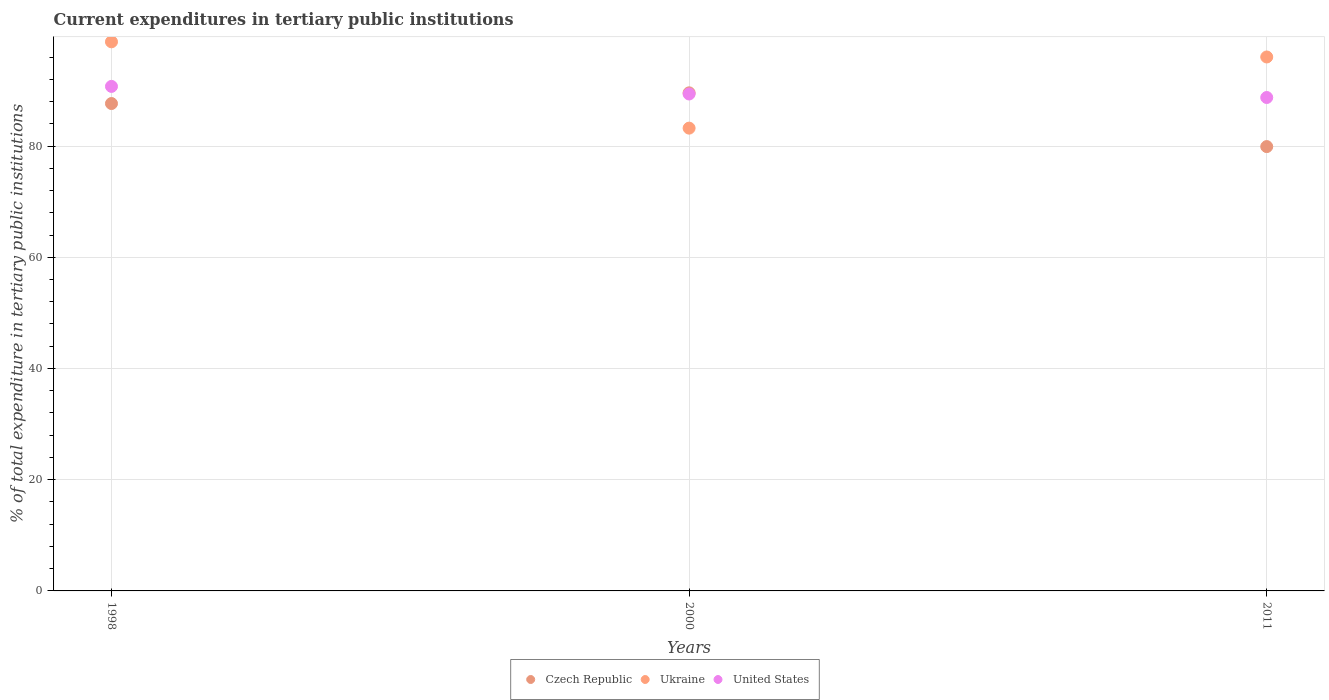How many different coloured dotlines are there?
Your answer should be very brief. 3. What is the current expenditures in tertiary public institutions in United States in 2000?
Offer a terse response. 89.36. Across all years, what is the maximum current expenditures in tertiary public institutions in United States?
Your response must be concise. 90.73. Across all years, what is the minimum current expenditures in tertiary public institutions in Czech Republic?
Provide a short and direct response. 79.9. In which year was the current expenditures in tertiary public institutions in United States maximum?
Give a very brief answer. 1998. In which year was the current expenditures in tertiary public institutions in Ukraine minimum?
Your answer should be compact. 2000. What is the total current expenditures in tertiary public institutions in Ukraine in the graph?
Offer a terse response. 277.98. What is the difference between the current expenditures in tertiary public institutions in United States in 2000 and that in 2011?
Make the answer very short. 0.63. What is the difference between the current expenditures in tertiary public institutions in United States in 2011 and the current expenditures in tertiary public institutions in Ukraine in 2000?
Give a very brief answer. 5.51. What is the average current expenditures in tertiary public institutions in Czech Republic per year?
Provide a succinct answer. 85.71. In the year 1998, what is the difference between the current expenditures in tertiary public institutions in United States and current expenditures in tertiary public institutions in Ukraine?
Keep it short and to the point. -8.02. In how many years, is the current expenditures in tertiary public institutions in Czech Republic greater than 72 %?
Keep it short and to the point. 3. What is the ratio of the current expenditures in tertiary public institutions in Ukraine in 1998 to that in 2000?
Keep it short and to the point. 1.19. What is the difference between the highest and the second highest current expenditures in tertiary public institutions in Czech Republic?
Offer a terse response. 1.92. What is the difference between the highest and the lowest current expenditures in tertiary public institutions in Czech Republic?
Ensure brevity in your answer.  9.67. In how many years, is the current expenditures in tertiary public institutions in Czech Republic greater than the average current expenditures in tertiary public institutions in Czech Republic taken over all years?
Your response must be concise. 2. Is the sum of the current expenditures in tertiary public institutions in Ukraine in 1998 and 2011 greater than the maximum current expenditures in tertiary public institutions in Czech Republic across all years?
Keep it short and to the point. Yes. How many years are there in the graph?
Give a very brief answer. 3. What is the difference between two consecutive major ticks on the Y-axis?
Offer a terse response. 20. Where does the legend appear in the graph?
Provide a short and direct response. Bottom center. How many legend labels are there?
Give a very brief answer. 3. How are the legend labels stacked?
Your response must be concise. Horizontal. What is the title of the graph?
Offer a very short reply. Current expenditures in tertiary public institutions. Does "Afghanistan" appear as one of the legend labels in the graph?
Offer a very short reply. No. What is the label or title of the Y-axis?
Keep it short and to the point. % of total expenditure in tertiary public institutions. What is the % of total expenditure in tertiary public institutions of Czech Republic in 1998?
Offer a very short reply. 87.65. What is the % of total expenditure in tertiary public institutions of Ukraine in 1998?
Provide a succinct answer. 98.74. What is the % of total expenditure in tertiary public institutions in United States in 1998?
Keep it short and to the point. 90.73. What is the % of total expenditure in tertiary public institutions of Czech Republic in 2000?
Make the answer very short. 89.57. What is the % of total expenditure in tertiary public institutions in Ukraine in 2000?
Provide a short and direct response. 83.22. What is the % of total expenditure in tertiary public institutions in United States in 2000?
Keep it short and to the point. 89.36. What is the % of total expenditure in tertiary public institutions in Czech Republic in 2011?
Offer a very short reply. 79.9. What is the % of total expenditure in tertiary public institutions of Ukraine in 2011?
Keep it short and to the point. 96.02. What is the % of total expenditure in tertiary public institutions in United States in 2011?
Your response must be concise. 88.73. Across all years, what is the maximum % of total expenditure in tertiary public institutions of Czech Republic?
Your response must be concise. 89.57. Across all years, what is the maximum % of total expenditure in tertiary public institutions in Ukraine?
Your answer should be compact. 98.74. Across all years, what is the maximum % of total expenditure in tertiary public institutions in United States?
Keep it short and to the point. 90.73. Across all years, what is the minimum % of total expenditure in tertiary public institutions of Czech Republic?
Provide a short and direct response. 79.9. Across all years, what is the minimum % of total expenditure in tertiary public institutions in Ukraine?
Provide a succinct answer. 83.22. Across all years, what is the minimum % of total expenditure in tertiary public institutions in United States?
Provide a succinct answer. 88.73. What is the total % of total expenditure in tertiary public institutions of Czech Republic in the graph?
Ensure brevity in your answer.  257.12. What is the total % of total expenditure in tertiary public institutions of Ukraine in the graph?
Make the answer very short. 277.98. What is the total % of total expenditure in tertiary public institutions of United States in the graph?
Offer a terse response. 268.82. What is the difference between the % of total expenditure in tertiary public institutions in Czech Republic in 1998 and that in 2000?
Your answer should be very brief. -1.92. What is the difference between the % of total expenditure in tertiary public institutions of Ukraine in 1998 and that in 2000?
Make the answer very short. 15.52. What is the difference between the % of total expenditure in tertiary public institutions of United States in 1998 and that in 2000?
Offer a terse response. 1.36. What is the difference between the % of total expenditure in tertiary public institutions of Czech Republic in 1998 and that in 2011?
Give a very brief answer. 7.74. What is the difference between the % of total expenditure in tertiary public institutions in Ukraine in 1998 and that in 2011?
Your response must be concise. 2.73. What is the difference between the % of total expenditure in tertiary public institutions in United States in 1998 and that in 2011?
Offer a very short reply. 2. What is the difference between the % of total expenditure in tertiary public institutions of Czech Republic in 2000 and that in 2011?
Ensure brevity in your answer.  9.67. What is the difference between the % of total expenditure in tertiary public institutions in Ukraine in 2000 and that in 2011?
Your response must be concise. -12.8. What is the difference between the % of total expenditure in tertiary public institutions of United States in 2000 and that in 2011?
Your response must be concise. 0.63. What is the difference between the % of total expenditure in tertiary public institutions of Czech Republic in 1998 and the % of total expenditure in tertiary public institutions of Ukraine in 2000?
Provide a succinct answer. 4.42. What is the difference between the % of total expenditure in tertiary public institutions of Czech Republic in 1998 and the % of total expenditure in tertiary public institutions of United States in 2000?
Your answer should be very brief. -1.72. What is the difference between the % of total expenditure in tertiary public institutions in Ukraine in 1998 and the % of total expenditure in tertiary public institutions in United States in 2000?
Your answer should be compact. 9.38. What is the difference between the % of total expenditure in tertiary public institutions of Czech Republic in 1998 and the % of total expenditure in tertiary public institutions of Ukraine in 2011?
Give a very brief answer. -8.37. What is the difference between the % of total expenditure in tertiary public institutions in Czech Republic in 1998 and the % of total expenditure in tertiary public institutions in United States in 2011?
Offer a very short reply. -1.09. What is the difference between the % of total expenditure in tertiary public institutions of Ukraine in 1998 and the % of total expenditure in tertiary public institutions of United States in 2011?
Your answer should be compact. 10.01. What is the difference between the % of total expenditure in tertiary public institutions of Czech Republic in 2000 and the % of total expenditure in tertiary public institutions of Ukraine in 2011?
Keep it short and to the point. -6.45. What is the difference between the % of total expenditure in tertiary public institutions of Czech Republic in 2000 and the % of total expenditure in tertiary public institutions of United States in 2011?
Keep it short and to the point. 0.84. What is the difference between the % of total expenditure in tertiary public institutions of Ukraine in 2000 and the % of total expenditure in tertiary public institutions of United States in 2011?
Your answer should be compact. -5.51. What is the average % of total expenditure in tertiary public institutions in Czech Republic per year?
Give a very brief answer. 85.71. What is the average % of total expenditure in tertiary public institutions in Ukraine per year?
Your answer should be compact. 92.66. What is the average % of total expenditure in tertiary public institutions in United States per year?
Keep it short and to the point. 89.61. In the year 1998, what is the difference between the % of total expenditure in tertiary public institutions of Czech Republic and % of total expenditure in tertiary public institutions of Ukraine?
Make the answer very short. -11.1. In the year 1998, what is the difference between the % of total expenditure in tertiary public institutions in Czech Republic and % of total expenditure in tertiary public institutions in United States?
Give a very brief answer. -3.08. In the year 1998, what is the difference between the % of total expenditure in tertiary public institutions in Ukraine and % of total expenditure in tertiary public institutions in United States?
Make the answer very short. 8.02. In the year 2000, what is the difference between the % of total expenditure in tertiary public institutions in Czech Republic and % of total expenditure in tertiary public institutions in Ukraine?
Offer a very short reply. 6.35. In the year 2000, what is the difference between the % of total expenditure in tertiary public institutions of Czech Republic and % of total expenditure in tertiary public institutions of United States?
Provide a short and direct response. 0.21. In the year 2000, what is the difference between the % of total expenditure in tertiary public institutions of Ukraine and % of total expenditure in tertiary public institutions of United States?
Your answer should be compact. -6.14. In the year 2011, what is the difference between the % of total expenditure in tertiary public institutions in Czech Republic and % of total expenditure in tertiary public institutions in Ukraine?
Your answer should be very brief. -16.11. In the year 2011, what is the difference between the % of total expenditure in tertiary public institutions in Czech Republic and % of total expenditure in tertiary public institutions in United States?
Give a very brief answer. -8.83. In the year 2011, what is the difference between the % of total expenditure in tertiary public institutions in Ukraine and % of total expenditure in tertiary public institutions in United States?
Provide a succinct answer. 7.29. What is the ratio of the % of total expenditure in tertiary public institutions in Czech Republic in 1998 to that in 2000?
Your answer should be very brief. 0.98. What is the ratio of the % of total expenditure in tertiary public institutions of Ukraine in 1998 to that in 2000?
Make the answer very short. 1.19. What is the ratio of the % of total expenditure in tertiary public institutions of United States in 1998 to that in 2000?
Your answer should be compact. 1.02. What is the ratio of the % of total expenditure in tertiary public institutions in Czech Republic in 1998 to that in 2011?
Give a very brief answer. 1.1. What is the ratio of the % of total expenditure in tertiary public institutions in Ukraine in 1998 to that in 2011?
Provide a short and direct response. 1.03. What is the ratio of the % of total expenditure in tertiary public institutions of United States in 1998 to that in 2011?
Ensure brevity in your answer.  1.02. What is the ratio of the % of total expenditure in tertiary public institutions in Czech Republic in 2000 to that in 2011?
Offer a very short reply. 1.12. What is the ratio of the % of total expenditure in tertiary public institutions of Ukraine in 2000 to that in 2011?
Offer a terse response. 0.87. What is the ratio of the % of total expenditure in tertiary public institutions of United States in 2000 to that in 2011?
Your answer should be very brief. 1.01. What is the difference between the highest and the second highest % of total expenditure in tertiary public institutions of Czech Republic?
Keep it short and to the point. 1.92. What is the difference between the highest and the second highest % of total expenditure in tertiary public institutions in Ukraine?
Keep it short and to the point. 2.73. What is the difference between the highest and the second highest % of total expenditure in tertiary public institutions of United States?
Offer a very short reply. 1.36. What is the difference between the highest and the lowest % of total expenditure in tertiary public institutions in Czech Republic?
Make the answer very short. 9.67. What is the difference between the highest and the lowest % of total expenditure in tertiary public institutions of Ukraine?
Provide a short and direct response. 15.52. What is the difference between the highest and the lowest % of total expenditure in tertiary public institutions of United States?
Offer a terse response. 2. 